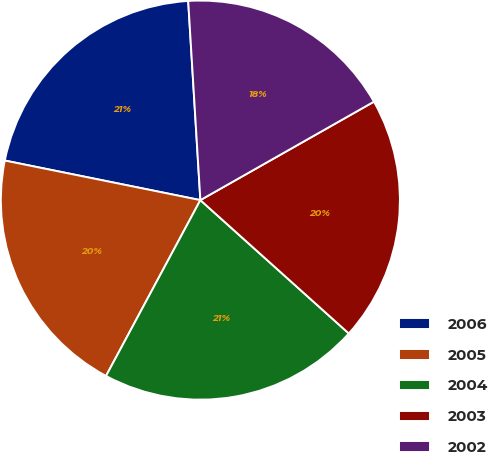Convert chart. <chart><loc_0><loc_0><loc_500><loc_500><pie_chart><fcel>2006<fcel>2005<fcel>2004<fcel>2003<fcel>2002<nl><fcel>20.85%<fcel>20.34%<fcel>21.19%<fcel>19.86%<fcel>17.76%<nl></chart> 